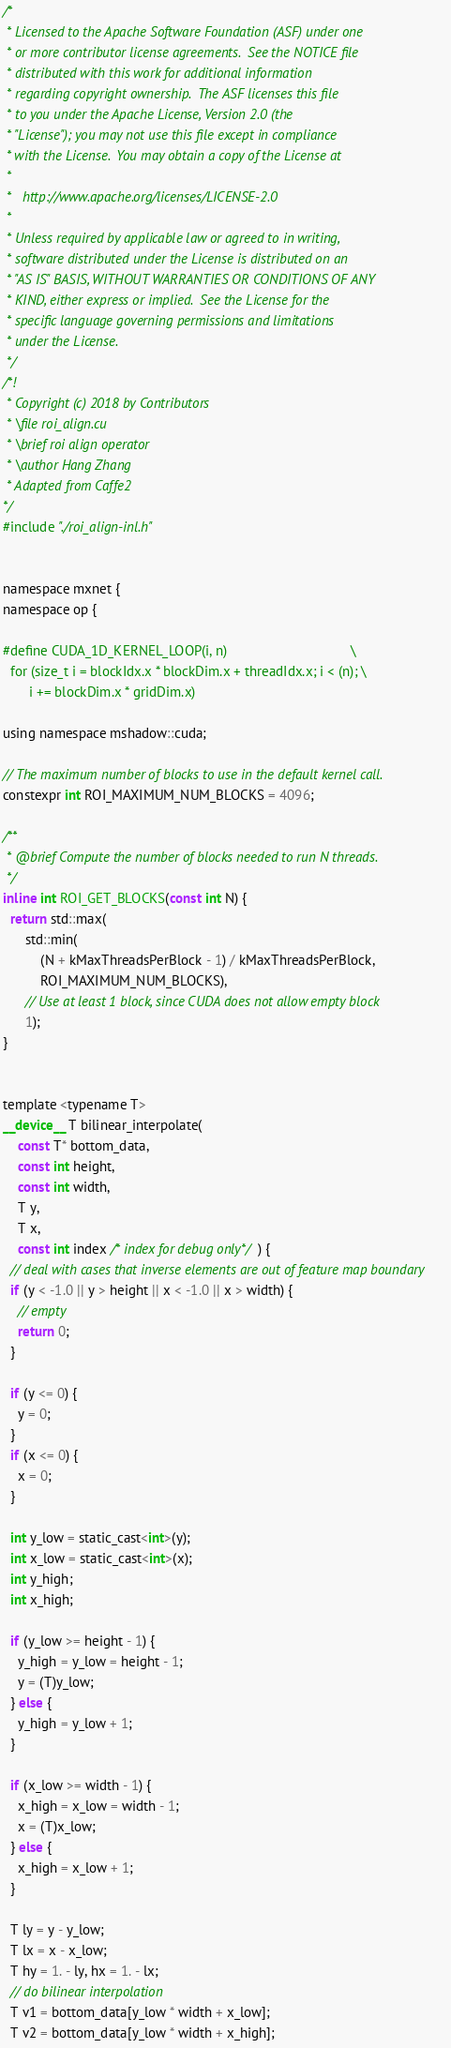<code> <loc_0><loc_0><loc_500><loc_500><_Cuda_>/*
 * Licensed to the Apache Software Foundation (ASF) under one
 * or more contributor license agreements.  See the NOTICE file
 * distributed with this work for additional information
 * regarding copyright ownership.  The ASF licenses this file
 * to you under the Apache License, Version 2.0 (the
 * "License"); you may not use this file except in compliance
 * with the License.  You may obtain a copy of the License at
 *
 *   http://www.apache.org/licenses/LICENSE-2.0
 *
 * Unless required by applicable law or agreed to in writing,
 * software distributed under the License is distributed on an
 * "AS IS" BASIS, WITHOUT WARRANTIES OR CONDITIONS OF ANY
 * KIND, either express or implied.  See the License for the
 * specific language governing permissions and limitations
 * under the License.
 */
/*!
 * Copyright (c) 2018 by Contributors
 * \file roi_align.cu
 * \brief roi align operator
 * \author Hang Zhang
 * Adapted from Caffe2
*/
#include "./roi_align-inl.h"


namespace mxnet {
namespace op {

#define CUDA_1D_KERNEL_LOOP(i, n)                                 \
  for (size_t i = blockIdx.x * blockDim.x + threadIdx.x; i < (n); \
       i += blockDim.x * gridDim.x)

using namespace mshadow::cuda;

// The maximum number of blocks to use in the default kernel call.
constexpr int ROI_MAXIMUM_NUM_BLOCKS = 4096;

/**
 * @brief Compute the number of blocks needed to run N threads.
 */
inline int ROI_GET_BLOCKS(const int N) {
  return std::max(
      std::min(
          (N + kMaxThreadsPerBlock - 1) / kMaxThreadsPerBlock,
          ROI_MAXIMUM_NUM_BLOCKS),
      // Use at least 1 block, since CUDA does not allow empty block
      1);
}


template <typename T>
__device__ T bilinear_interpolate(
    const T* bottom_data,
    const int height,
    const int width,
    T y,
    T x,
    const int index /* index for debug only*/) {
  // deal with cases that inverse elements are out of feature map boundary
  if (y < -1.0 || y > height || x < -1.0 || x > width) {
    // empty
    return 0;
  }

  if (y <= 0) {
    y = 0;
  }
  if (x <= 0) {
    x = 0;
  }

  int y_low = static_cast<int>(y);
  int x_low = static_cast<int>(x);
  int y_high;
  int x_high;

  if (y_low >= height - 1) {
    y_high = y_low = height - 1;
    y = (T)y_low;
  } else {
    y_high = y_low + 1;
  }

  if (x_low >= width - 1) {
    x_high = x_low = width - 1;
    x = (T)x_low;
  } else {
    x_high = x_low + 1;
  }

  T ly = y - y_low;
  T lx = x - x_low;
  T hy = 1. - ly, hx = 1. - lx;
  // do bilinear interpolation
  T v1 = bottom_data[y_low * width + x_low];
  T v2 = bottom_data[y_low * width + x_high];</code> 